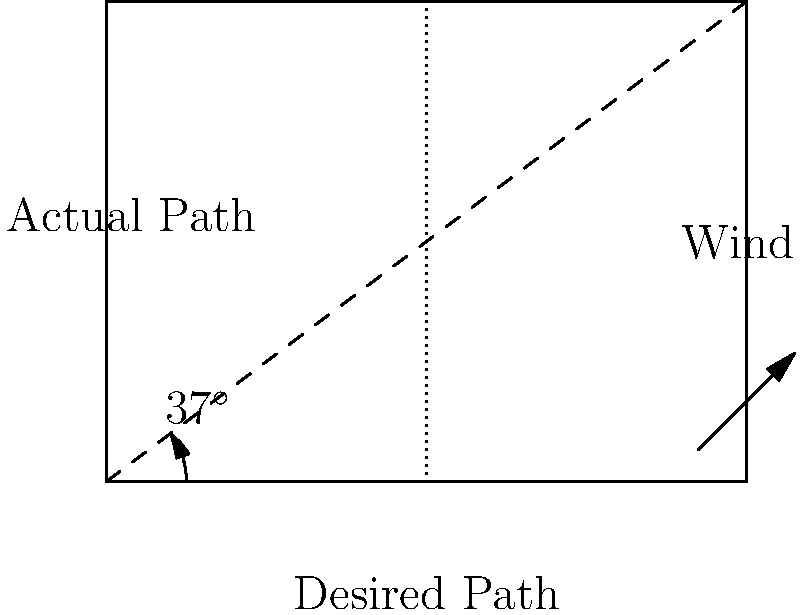A helicopter needs to fly from point A to point B, a distance of 50 km due east. There is a crosswind from the south with a speed of 30 km/h. If the helicopter's airspeed is 150 km/h, what should be the heading angle (in degrees) for the helicopter to reach its destination? To solve this problem, we need to use vector addition and trigonometry. Let's break it down step by step:

1) First, let's define our vectors:
   - Desired path: 50 km east
   - Wind: 30 km/h from south
   - Helicopter's airspeed: 150 km/h in the direction we need to calculate

2) We can represent this as a right-angled triangle, where:
   - The hypotenuse is the helicopter's airspeed vector
   - One side is the desired path (east)
   - The other side is the wind vector (south)

3) We need to find the angle between the hypotenuse and the desired path. Let's call this angle $\theta$.

4) We can use the sine function to relate the wind speed to the helicopter's airspeed:

   $$\sin(\theta) = \frac{\text{opposite}}{\text{hypotenuse}} = \frac{30}{150} = 0.2$$

5) To find $\theta$, we take the inverse sine (arcsin):

   $$\theta = \arcsin(0.2) \approx 11.54^\circ$$

6) However, this angle is measured from the desired path. The heading is measured from north, so we need to subtract this from 90°:

   $$\text{Heading} = 90^\circ - 11.54^\circ = 78.46^\circ$$

7) Rounding to the nearest degree, we get 78°.
Answer: 78° 